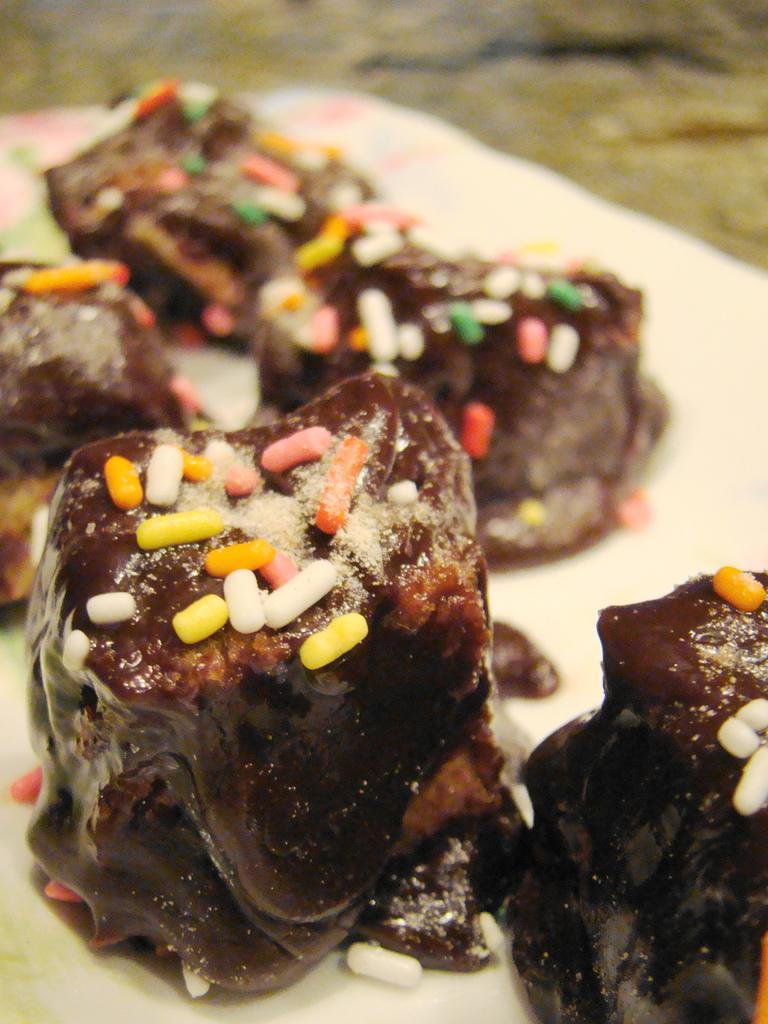Could you give a brief overview of what you see in this image? In this picture I can see the food in a plate. 